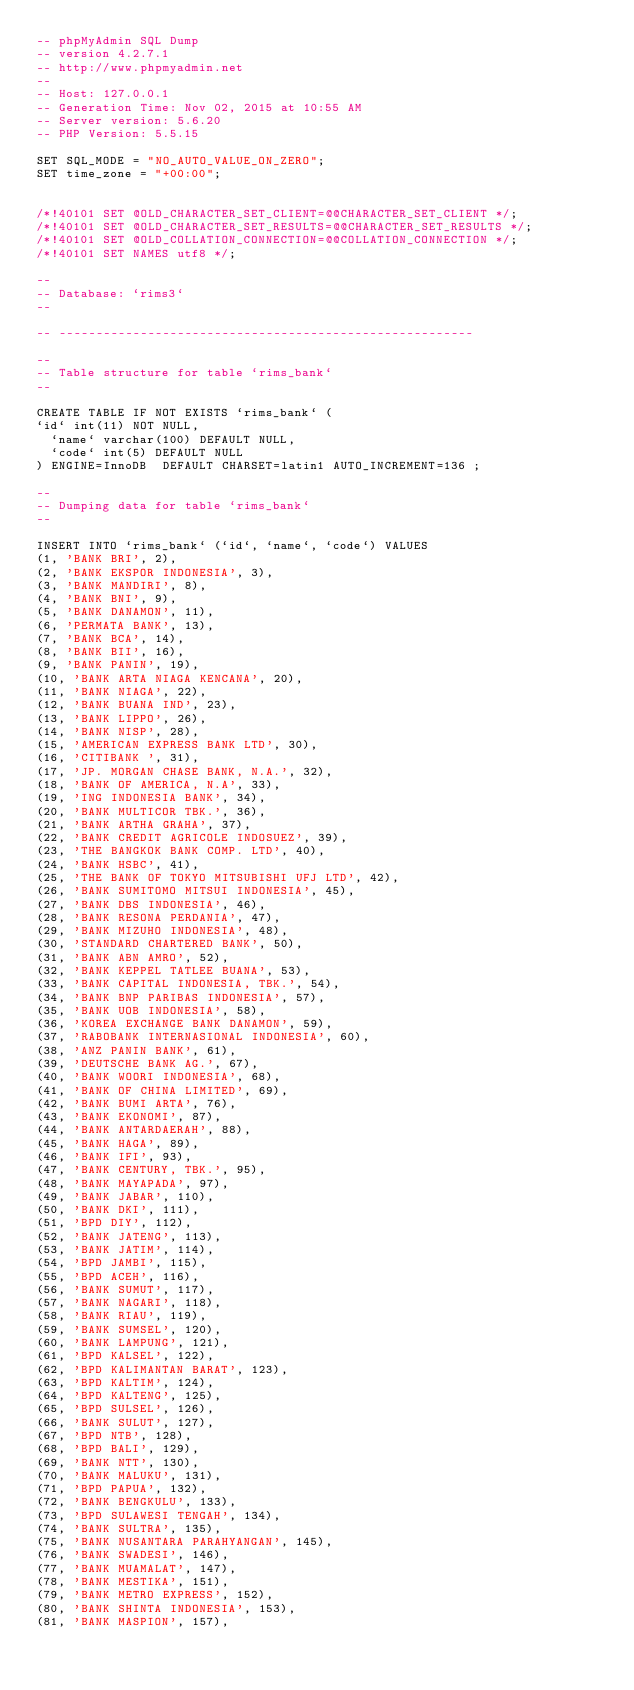Convert code to text. <code><loc_0><loc_0><loc_500><loc_500><_SQL_>-- phpMyAdmin SQL Dump
-- version 4.2.7.1
-- http://www.phpmyadmin.net
--
-- Host: 127.0.0.1
-- Generation Time: Nov 02, 2015 at 10:55 AM
-- Server version: 5.6.20
-- PHP Version: 5.5.15

SET SQL_MODE = "NO_AUTO_VALUE_ON_ZERO";
SET time_zone = "+00:00";


/*!40101 SET @OLD_CHARACTER_SET_CLIENT=@@CHARACTER_SET_CLIENT */;
/*!40101 SET @OLD_CHARACTER_SET_RESULTS=@@CHARACTER_SET_RESULTS */;
/*!40101 SET @OLD_COLLATION_CONNECTION=@@COLLATION_CONNECTION */;
/*!40101 SET NAMES utf8 */;

--
-- Database: `rims3`
--

-- --------------------------------------------------------

--
-- Table structure for table `rims_bank`
--

CREATE TABLE IF NOT EXISTS `rims_bank` (
`id` int(11) NOT NULL,
  `name` varchar(100) DEFAULT NULL,
  `code` int(5) DEFAULT NULL
) ENGINE=InnoDB  DEFAULT CHARSET=latin1 AUTO_INCREMENT=136 ;

--
-- Dumping data for table `rims_bank`
--

INSERT INTO `rims_bank` (`id`, `name`, `code`) VALUES
(1, 'BANK BRI', 2),
(2, 'BANK EKSPOR INDONESIA', 3),
(3, 'BANK MANDIRI', 8),
(4, 'BANK BNI', 9),
(5, 'BANK DANAMON', 11),
(6, 'PERMATA BANK', 13),
(7, 'BANK BCA', 14),
(8, 'BANK BII', 16),
(9, 'BANK PANIN', 19),
(10, 'BANK ARTA NIAGA KENCANA', 20),
(11, 'BANK NIAGA', 22),
(12, 'BANK BUANA IND', 23),
(13, 'BANK LIPPO', 26),
(14, 'BANK NISP', 28),
(15, 'AMERICAN EXPRESS BANK LTD', 30),
(16, 'CITIBANK ', 31),
(17, 'JP. MORGAN CHASE BANK, N.A.', 32),
(18, 'BANK OF AMERICA, N.A', 33),
(19, 'ING INDONESIA BANK', 34),
(20, 'BANK MULTICOR TBK.', 36),
(21, 'BANK ARTHA GRAHA', 37),
(22, 'BANK CREDIT AGRICOLE INDOSUEZ', 39),
(23, 'THE BANGKOK BANK COMP. LTD', 40),
(24, 'BANK HSBC', 41),
(25, 'THE BANK OF TOKYO MITSUBISHI UFJ LTD', 42),
(26, 'BANK SUMITOMO MITSUI INDONESIA', 45),
(27, 'BANK DBS INDONESIA', 46),
(28, 'BANK RESONA PERDANIA', 47),
(29, 'BANK MIZUHO INDONESIA', 48),
(30, 'STANDARD CHARTERED BANK', 50),
(31, 'BANK ABN AMRO', 52),
(32, 'BANK KEPPEL TATLEE BUANA', 53),
(33, 'BANK CAPITAL INDONESIA, TBK.', 54),
(34, 'BANK BNP PARIBAS INDONESIA', 57),
(35, 'BANK UOB INDONESIA', 58),
(36, 'KOREA EXCHANGE BANK DANAMON', 59),
(37, 'RABOBANK INTERNASIONAL INDONESIA', 60),
(38, 'ANZ PANIN BANK', 61),
(39, 'DEUTSCHE BANK AG.', 67),
(40, 'BANK WOORI INDONESIA', 68),
(41, 'BANK OF CHINA LIMITED', 69),
(42, 'BANK BUMI ARTA', 76),
(43, 'BANK EKONOMI', 87),
(44, 'BANK ANTARDAERAH', 88),
(45, 'BANK HAGA', 89),
(46, 'BANK IFI', 93),
(47, 'BANK CENTURY, TBK.', 95),
(48, 'BANK MAYAPADA', 97),
(49, 'BANK JABAR', 110),
(50, 'BANK DKI', 111),
(51, 'BPD DIY', 112),
(52, 'BANK JATENG', 113),
(53, 'BANK JATIM', 114),
(54, 'BPD JAMBI', 115),
(55, 'BPD ACEH', 116),
(56, 'BANK SUMUT', 117),
(57, 'BANK NAGARI', 118),
(58, 'BANK RIAU', 119),
(59, 'BANK SUMSEL', 120),
(60, 'BANK LAMPUNG', 121),
(61, 'BPD KALSEL', 122),
(62, 'BPD KALIMANTAN BARAT', 123),
(63, 'BPD KALTIM', 124),
(64, 'BPD KALTENG', 125),
(65, 'BPD SULSEL', 126),
(66, 'BANK SULUT', 127),
(67, 'BPD NTB', 128),
(68, 'BPD BALI', 129),
(69, 'BANK NTT', 130),
(70, 'BANK MALUKU', 131),
(71, 'BPD PAPUA', 132),
(72, 'BANK BENGKULU', 133),
(73, 'BPD SULAWESI TENGAH', 134),
(74, 'BANK SULTRA', 135),
(75, 'BANK NUSANTARA PARAHYANGAN', 145),
(76, 'BANK SWADESI', 146),
(77, 'BANK MUAMALAT', 147),
(78, 'BANK MESTIKA', 151),
(79, 'BANK METRO EXPRESS', 152),
(80, 'BANK SHINTA INDONESIA', 153),
(81, 'BANK MASPION', 157),</code> 